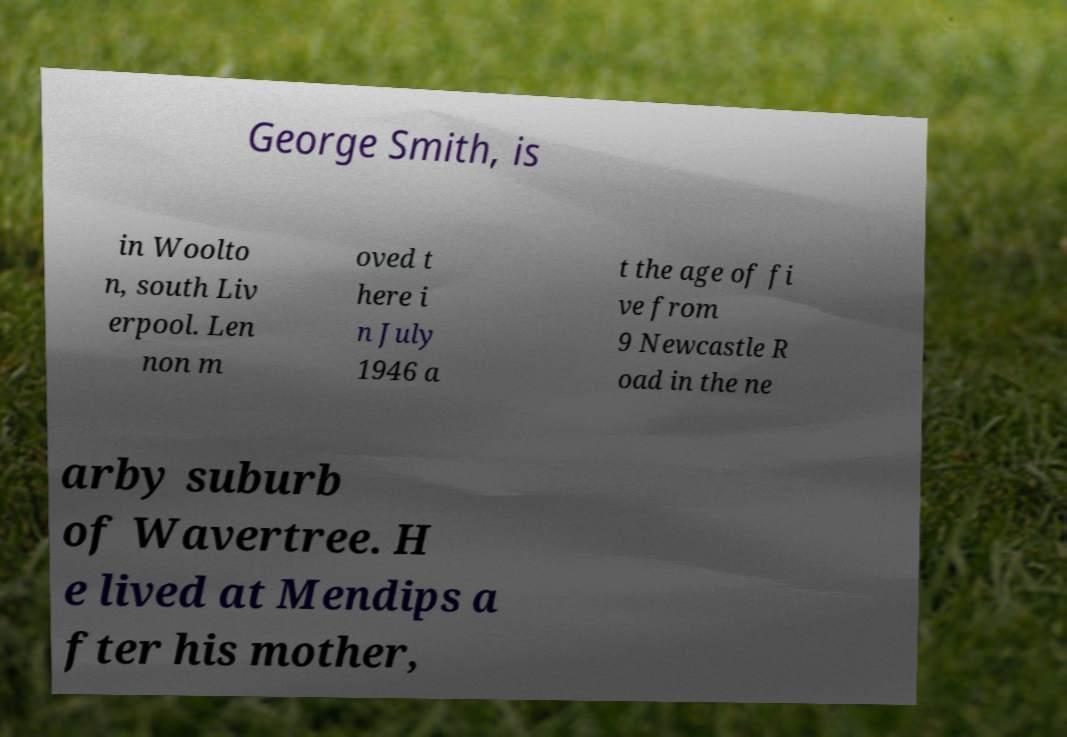Can you accurately transcribe the text from the provided image for me? George Smith, is in Woolto n, south Liv erpool. Len non m oved t here i n July 1946 a t the age of fi ve from 9 Newcastle R oad in the ne arby suburb of Wavertree. H e lived at Mendips a fter his mother, 